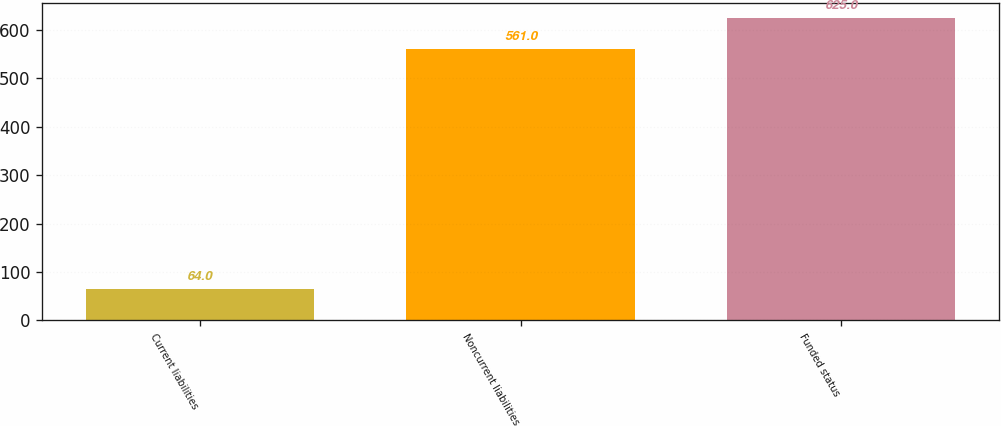Convert chart. <chart><loc_0><loc_0><loc_500><loc_500><bar_chart><fcel>Current liabilities<fcel>Noncurrent liabilities<fcel>Funded status<nl><fcel>64<fcel>561<fcel>625<nl></chart> 